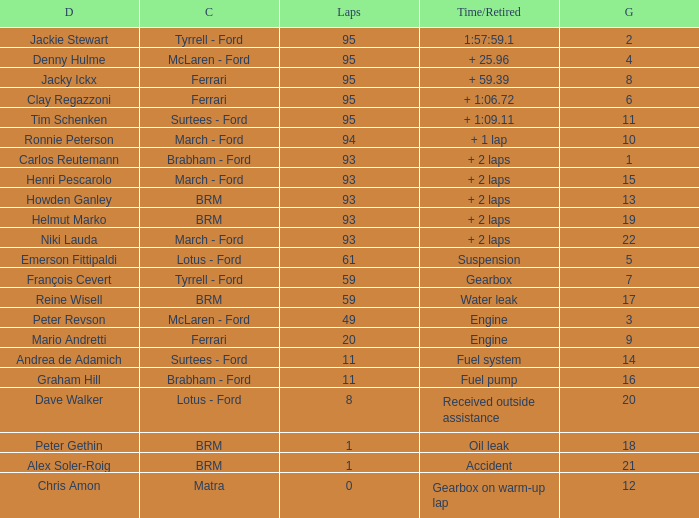Which grid has less than 11 laps, and a Time/Retired of accident? 21.0. 